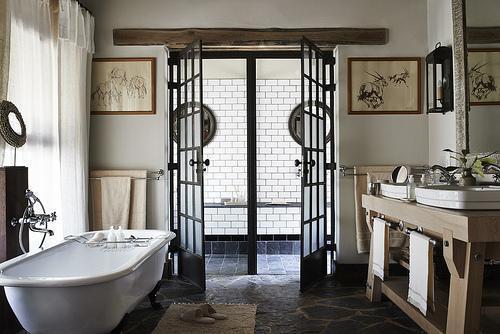How many sinks?
Give a very brief answer. 2. 